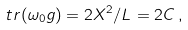Convert formula to latex. <formula><loc_0><loc_0><loc_500><loc_500>\ t r ( \omega _ { 0 } g ) = 2 X ^ { 2 } / L = 2 { C } \, ,</formula> 